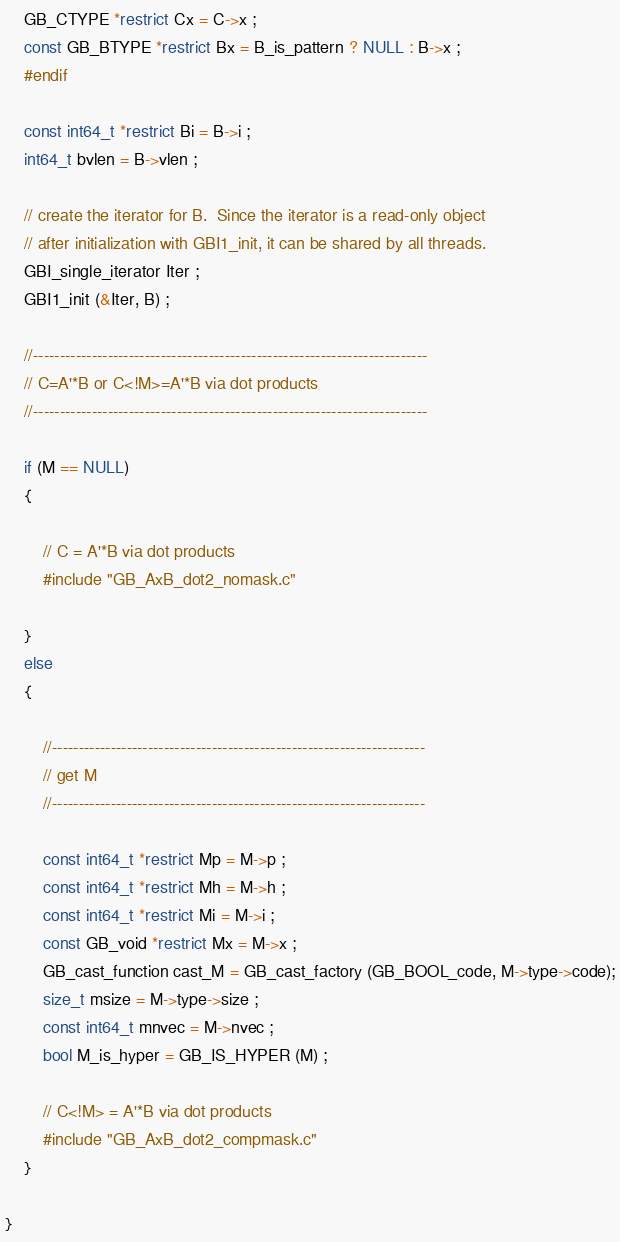Convert code to text. <code><loc_0><loc_0><loc_500><loc_500><_C_>    GB_CTYPE *restrict Cx = C->x ;
    const GB_BTYPE *restrict Bx = B_is_pattern ? NULL : B->x ;
    #endif

    const int64_t *restrict Bi = B->i ;
    int64_t bvlen = B->vlen ;

    // create the iterator for B.  Since the iterator is a read-only object
    // after initialization with GBI1_init, it can be shared by all threads.
    GBI_single_iterator Iter ;
    GBI1_init (&Iter, B) ;

    //--------------------------------------------------------------------------
    // C=A'*B or C<!M>=A'*B via dot products
    //--------------------------------------------------------------------------

    if (M == NULL)
    { 

        // C = A'*B via dot products
        #include "GB_AxB_dot2_nomask.c"

    }
    else
    {

        //----------------------------------------------------------------------
        // get M
        //----------------------------------------------------------------------

        const int64_t *restrict Mp = M->p ;
        const int64_t *restrict Mh = M->h ;
        const int64_t *restrict Mi = M->i ;
        const GB_void *restrict Mx = M->x ;
        GB_cast_function cast_M = GB_cast_factory (GB_BOOL_code, M->type->code);
        size_t msize = M->type->size ;
        const int64_t mnvec = M->nvec ;
        bool M_is_hyper = GB_IS_HYPER (M) ;

        // C<!M> = A'*B via dot products
        #include "GB_AxB_dot2_compmask.c"
    }

}

</code> 